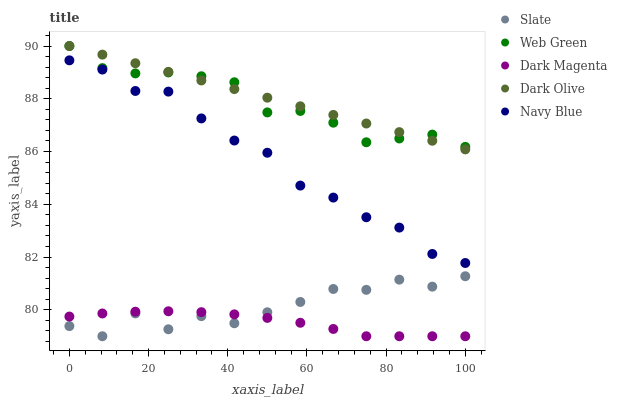Does Dark Magenta have the minimum area under the curve?
Answer yes or no. Yes. Does Dark Olive have the maximum area under the curve?
Answer yes or no. Yes. Does Slate have the minimum area under the curve?
Answer yes or no. No. Does Slate have the maximum area under the curve?
Answer yes or no. No. Is Dark Olive the smoothest?
Answer yes or no. Yes. Is Slate the roughest?
Answer yes or no. Yes. Is Slate the smoothest?
Answer yes or no. No. Is Dark Olive the roughest?
Answer yes or no. No. Does Slate have the lowest value?
Answer yes or no. Yes. Does Dark Olive have the lowest value?
Answer yes or no. No. Does Web Green have the highest value?
Answer yes or no. Yes. Does Slate have the highest value?
Answer yes or no. No. Is Navy Blue less than Dark Olive?
Answer yes or no. Yes. Is Web Green greater than Slate?
Answer yes or no. Yes. Does Dark Magenta intersect Slate?
Answer yes or no. Yes. Is Dark Magenta less than Slate?
Answer yes or no. No. Is Dark Magenta greater than Slate?
Answer yes or no. No. Does Navy Blue intersect Dark Olive?
Answer yes or no. No. 